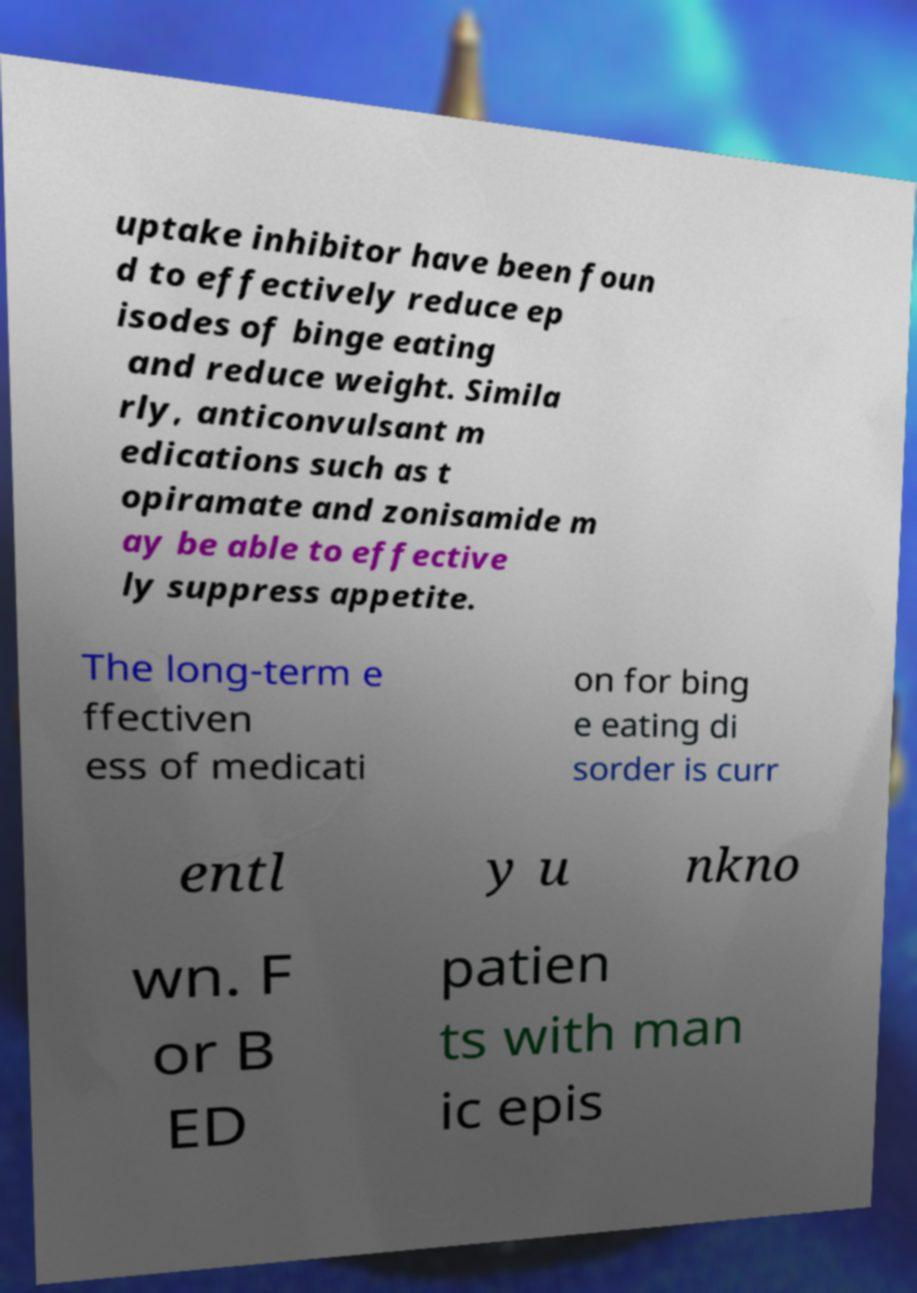What messages or text are displayed in this image? I need them in a readable, typed format. uptake inhibitor have been foun d to effectively reduce ep isodes of binge eating and reduce weight. Simila rly, anticonvulsant m edications such as t opiramate and zonisamide m ay be able to effective ly suppress appetite. The long-term e ffectiven ess of medicati on for bing e eating di sorder is curr entl y u nkno wn. F or B ED patien ts with man ic epis 